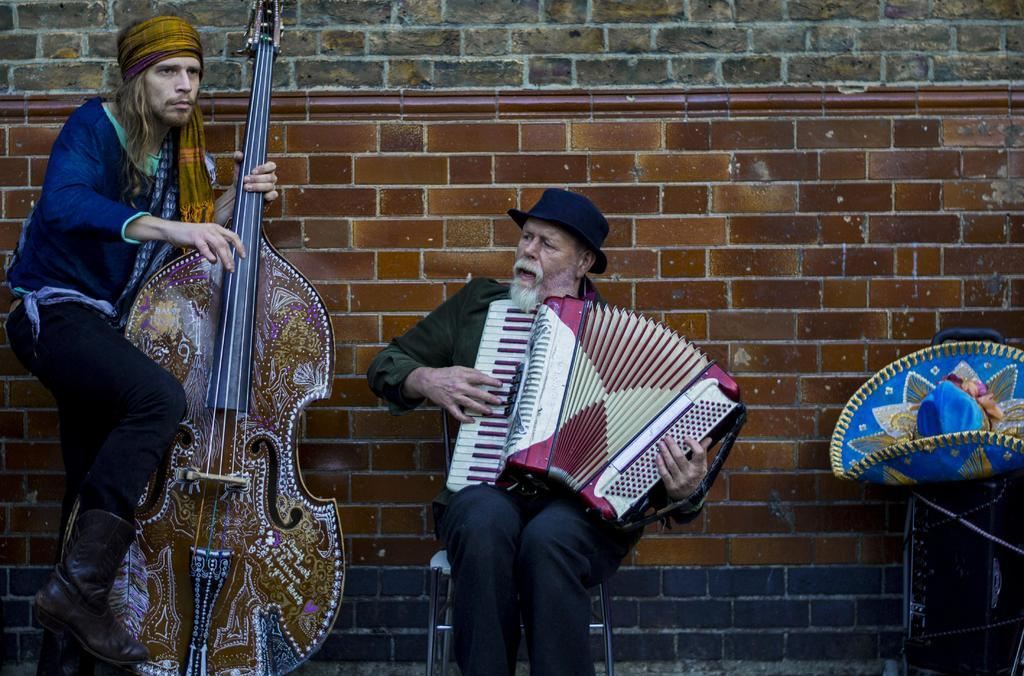How many people are present in the image? There are two people in the image. What are the people doing in the image? The people are holding musical instruments in their hands. What can be seen in the background of the image? There is a wall, a cap, and some objects in the background of the image. What type of bread can be seen in the image? There is no bread present in the image. 